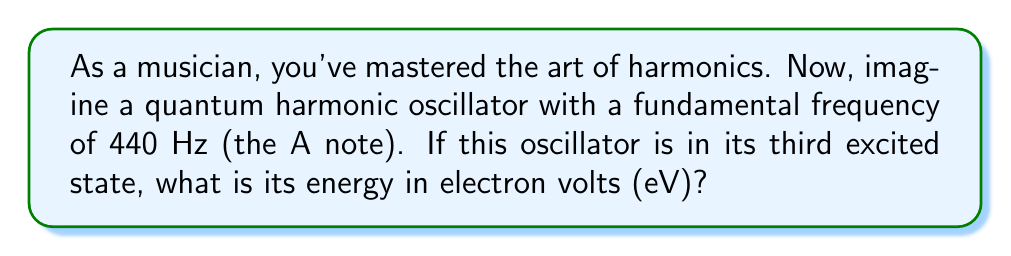Show me your answer to this math problem. Let's approach this step-by-step:

1) The energy of a quantum harmonic oscillator in the nth state is given by:

   $$E_n = \hbar \omega (n + \frac{1}{2})$$

   where $\hbar$ is the reduced Planck's constant, $\omega$ is the angular frequency, and n is the quantum number.

2) We're given the third excited state, which means n = 3.

3) We need to convert the frequency f to angular frequency $\omega$:
   
   $$\omega = 2\pi f = 2\pi \cdot 440 \text{ Hz} = 2763.89 \text{ rad/s}$$

4) Now, let's substitute these values into our energy equation:

   $$E_3 = \hbar \cdot 2763.89 \cdot (3 + \frac{1}{2})$$

5) The value of $\hbar$ in eV·s is approximately $6.582 \times 10^{-16}$ eV·s.

6) Substituting this value:

   $$E_3 = (6.582 \times 10^{-16} \text{ eV·s}) \cdot 2763.89 \text{ rad/s} \cdot 3.5$$

7) Calculating:

   $$E_3 = 6.37 \times 10^{-12} \text{ eV}$$

8) This is a very small energy in eV, so let's convert it to meV (milli-electronvolts):

   $$E_3 = 6.37 \times 10^{-9} \text{ meV}$$
Answer: $6.37 \times 10^{-9} \text{ meV}$ 